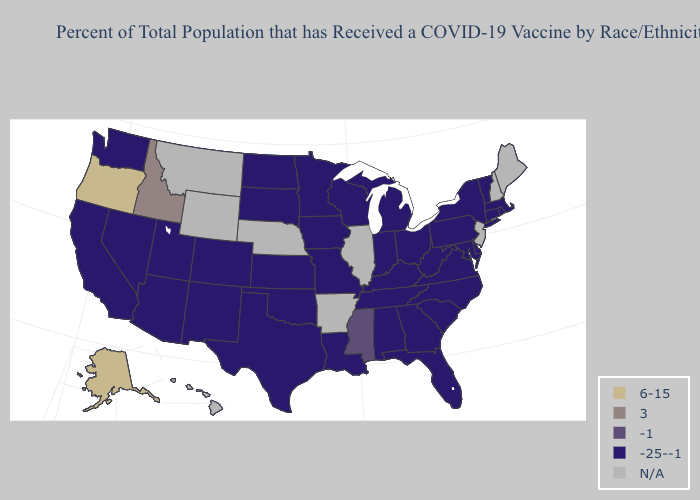What is the value of Vermont?
Concise answer only. -25--1. Does Alaska have the lowest value in the USA?
Short answer required. No. What is the lowest value in the MidWest?
Short answer required. -25--1. Name the states that have a value in the range 6-15?
Keep it brief. Alaska, Oregon. Which states have the highest value in the USA?
Keep it brief. Alaska, Oregon. Which states have the highest value in the USA?
Give a very brief answer. Alaska, Oregon. Name the states that have a value in the range N/A?
Concise answer only. Arkansas, Hawaii, Illinois, Maine, Montana, Nebraska, New Hampshire, New Jersey, Wyoming. What is the value of Mississippi?
Write a very short answer. -1. What is the value of Wyoming?
Answer briefly. N/A. What is the value of Idaho?
Short answer required. 3. What is the value of Illinois?
Be succinct. N/A. Does Kentucky have the lowest value in the South?
Quick response, please. Yes. 